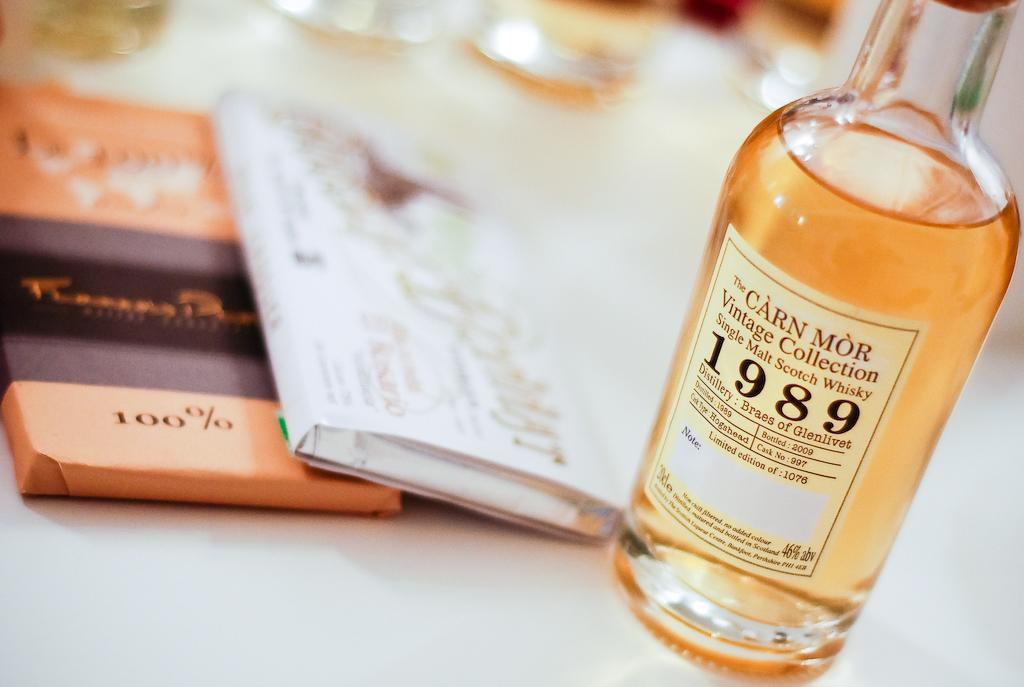What piece of furniture is present in the image? There is a table in the image. What is on the table? There is a bottle containing a drink and books on the table. What can be inferred about the bottle from the image? The bottle has a label attached to it. What type of bed is visible in the image? There is no bed present in the image. How does the bucket contribute to the overall interest of the image? There is no bucket present in the image, so it cannot contribute to the overall interest. 